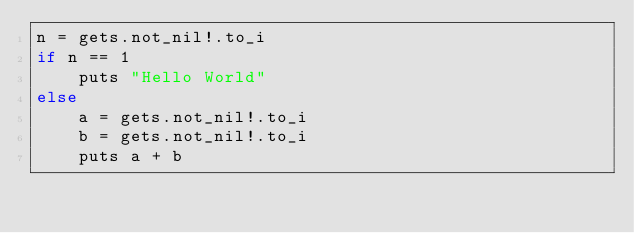<code> <loc_0><loc_0><loc_500><loc_500><_Crystal_>n = gets.not_nil!.to_i
if n == 1
	puts "Hello World"
else
	a = gets.not_nil!.to_i
	b = gets.not_nil!.to_i
	puts a + b</code> 